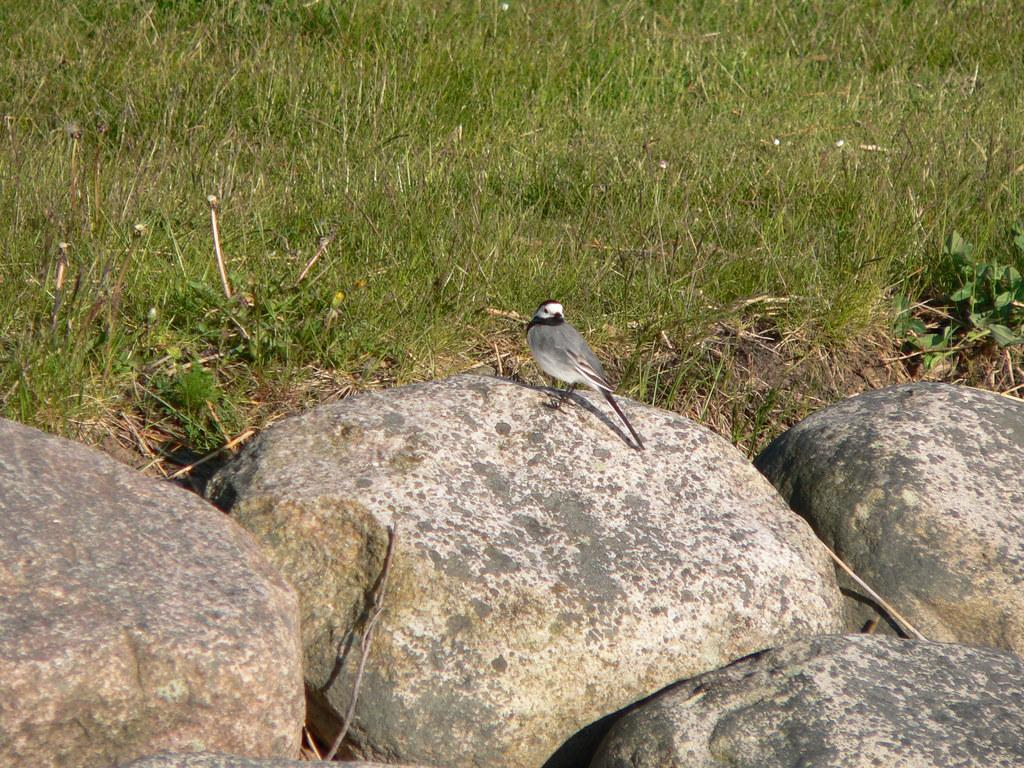What type of animal can be seen in the picture? There is a bird in the picture. What is the bird standing on? The bird is standing on a rock. What can be seen in the background of the picture? There is grass and rocks in the background of the picture. What type of note is the bird holding in its beak in the picture? There is no note present in the image; the bird is not holding anything in its beak. 